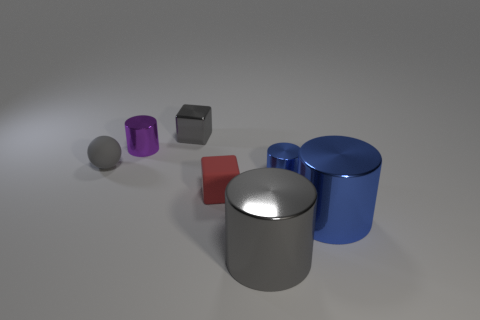Subtract all red cubes. How many blue cylinders are left? 2 Subtract all tiny purple cylinders. How many cylinders are left? 3 Subtract all gray cylinders. How many cylinders are left? 3 Add 1 gray matte balls. How many objects exist? 8 Subtract all spheres. How many objects are left? 6 Add 6 gray matte balls. How many gray matte balls are left? 7 Add 5 tiny red blocks. How many tiny red blocks exist? 6 Subtract 0 cyan spheres. How many objects are left? 7 Subtract all green balls. Subtract all red cubes. How many balls are left? 1 Subtract all tiny blue objects. Subtract all small gray blocks. How many objects are left? 5 